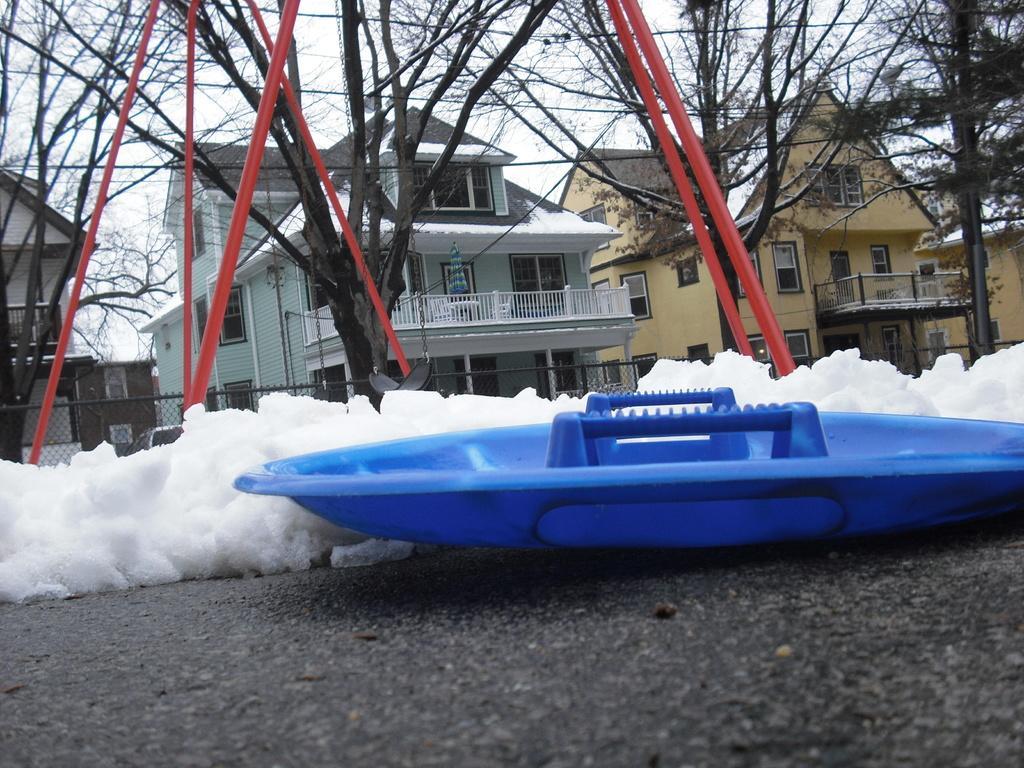How would you summarize this image in a sentence or two? This image consists of buildings. At the bottom, there is a road on which we can see the snow. And and object in blue color. In the middle, there are trees. At the top, there is sky. And we can see the poles in red color. 